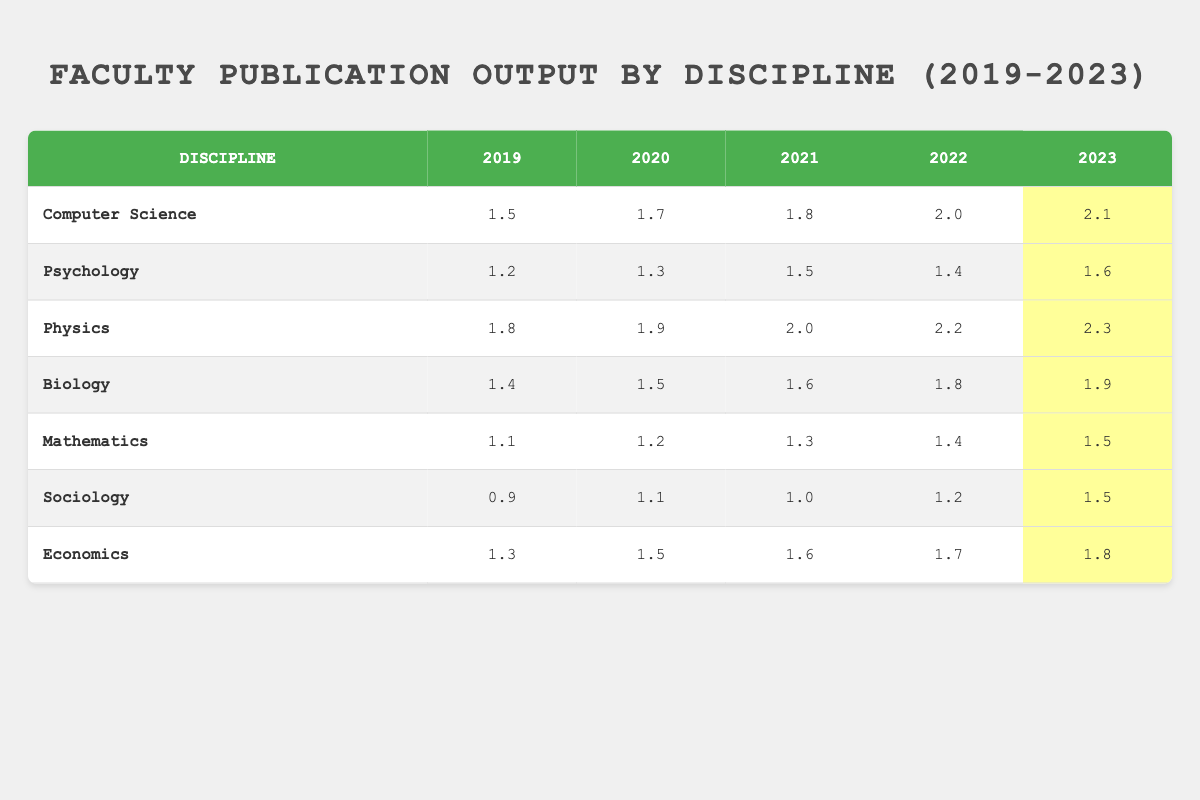What was the publication count for Physics in 2023? In the table, locate the row for the discipline "Physics" and then look at the column for the year 2023. The value in that cell is 2.3.
Answer: 2.3 Which discipline had the highest publication output in 2022? Compare the publication numbers for each discipline in the year 2022. The highest value is found in "Physics" with 2.2.
Answer: Physics What is the average number of publications for Psychology over the five years? Sum the publication counts for Psychology: (1.2 + 1.3 + 1.5 + 1.4 + 1.6) = 6.0. Then, divide by 5 to find the average: 6.0 / 5 = 1.2.
Answer: 1.2 Did Sociology have a consistent increase in publications from 2019 to 2023? Check the publication output for Sociology from 2019 to 2023: 0.9, 1.1, 1.0, 1.2, 1.5. The value in 2021 decreased compared to 2020, indicating it did not consistently increase.
Answer: No What was the difference in publication output between Biology and Computer Science in 2021? From the table, identify the publication counts for both disciplines in 2021: Biology had 1.6 and Computer Science had 1.8. The difference is 1.8 - 1.6 = 0.2.
Answer: 0.2 How many disciplines published more than 1.5 publications in 2023? Check the 2023 column for each discipline. The ones with more than 1.5 are: Computer Science (2.1), Physics (2.3), Biology (1.9), Economics (1.8). There are four disciplines meeting the criteria.
Answer: 4 What is the total number of publications from all disciplines in 2022? Add the publication counts for all disciplines in 2022: 2.0 (CS) + 1.4 (Psychology) + 2.2 (Physics) + 1.8 (Biology) + 1.4 (Mathematics) + 1.2 (Sociology) + 1.7 (Economics) = 11.7.
Answer: 11.7 Which discipline showed the largest increase in publication output from 2019 to 2023? Analyze the change in publication counts from 2019 to 2023 for each discipline. The largest increase is from Physics, going from 1.8 in 2019 to 2.3 in 2023, a rise of 0.5.
Answer: Physics 